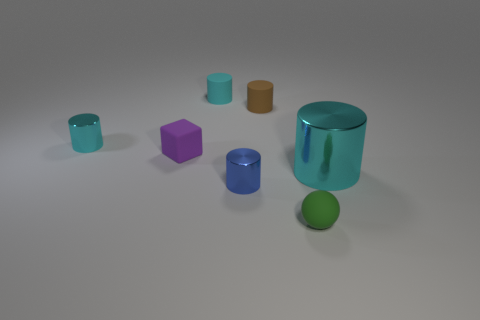What shape is the rubber thing in front of the cyan metallic cylinder that is in front of the tiny cyan metal cylinder? The rubber object in front of the cyan metallic cylinder, which is positioned in front of the smaller cyan cylinder, is spherical in shape. 